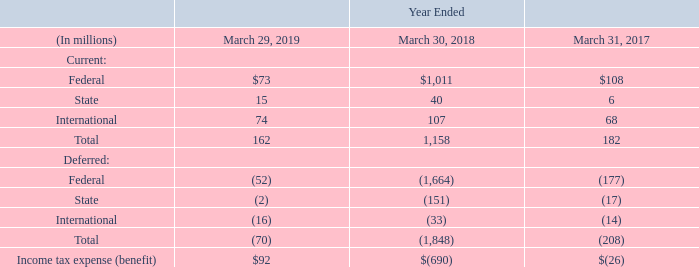Pre-tax income from international operations was $214 million, $890 million, and $353 million for fiscal 2019, 2018, and 2017, respectively.
The components of income tax expense (benefit) recorded in continuing operations are as follows:
As of December 28, 2018, we have completed our accounting for the effects of the enactment of the Tax Cuts and Jobs Act (H.R.1) (the 2017 Tax Act) in accordance with U.S. Securities and Exchange Commission (SEC) Staff Accounting Bulletin No. 118, and the amounts are no longer considered provisional. We will continue to evaluate any new guidance from the U.S. Department of Treasury and the Internal Revenue Service (IRS) as issued.
What does the table show? Components of income tax expense (benefit) recorded in continuing operations. What is the Pre-tax income from international operations for fiscal 2019? $214 million. What is the Pre-tax income from international operations for fiscal 2018? $890 million. What is the income tax expense for Federal for year ended March 29, 2019 expressed as a percentage of total income tax expenses?
Answer scale should be: percent. 73/162
Answer: 45.06. What is the summed Total current income tax expense for the fiscal years 2017, 2018 and 2019?
Answer scale should be: million. 162+1,158+182
Answer: 1502. What is the average Total current income tax expense for the fiscal years 2017, 2018 and 2019?
Answer scale should be: million. (162+1,158+182)/3
Answer: 500.67. 